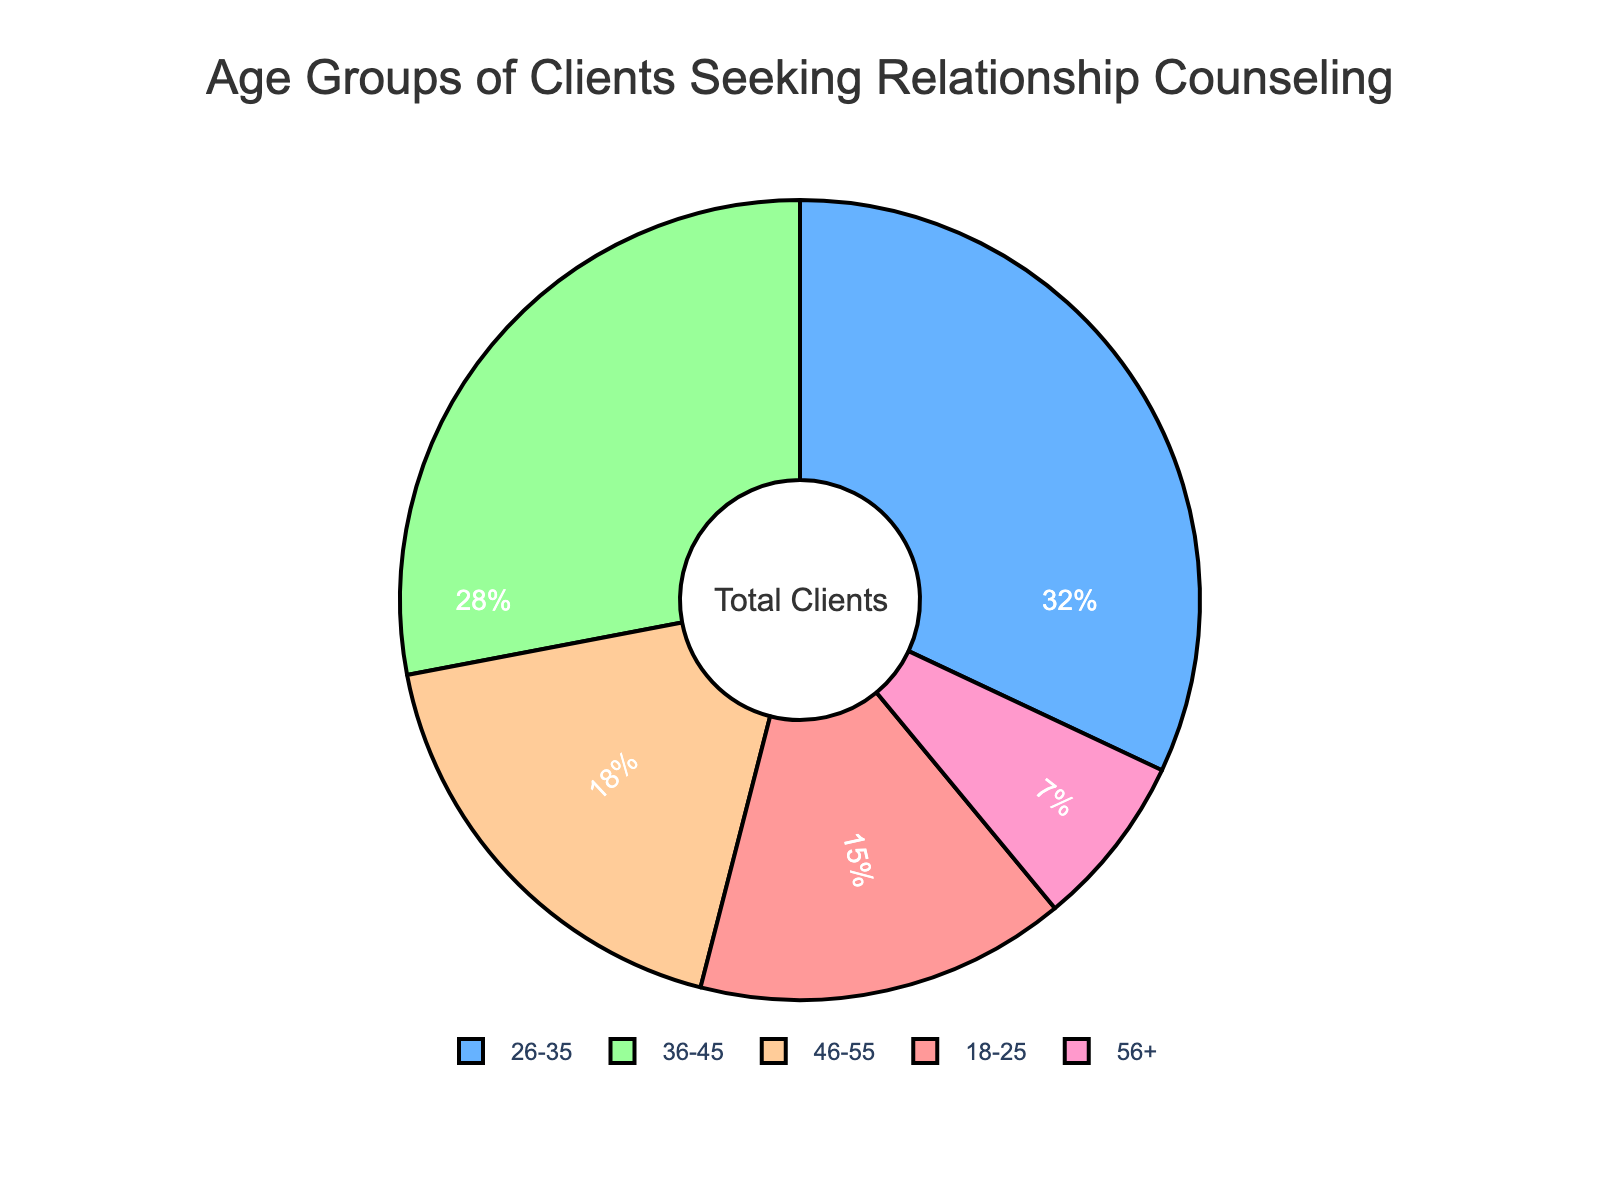What percentage of the clients are aged 26-35? By observing the pie chart, locate the section labeled '26-35' and check the associated percentage value.
Answer: 32% Which age group has the smallest percentage of clients? Identify the sections in the pie chart and compare their sizes. The smallest section corresponds to the age group with the smallest percentage.
Answer: 56+ How much more percentage do clients aged 26-35 have compared to those aged 56+? Find the percentages of clients for the age groups 26-35 and 56+ in the pie chart. Calculate the difference: 32% - 7% = 25%.
Answer: 25% What is the combined percentage of clients aged 36-45 and 46-55? Locate the percentages for age groups 36-45 and 46-55 in the pie chart. Sum the values: 28% + 18% = 46%.
Answer: 46% Which age group has a larger percentage of clients: 18-25 or 46-55? Compare the percentages of the 18-25 and 46-55 age groups. Find the larger one.
Answer: 46-55 What are the colors representing the age groups 26-35 and 56+? Observe the colors of the sections labeled '26-35' and '56+' in the pie chart.
Answer: Light blue (26-35), pink (56+) How many age groups have a percentage higher than 20%? Analyze the pie chart and count the number of sections with percentages greater than 20%.
Answer: 2 (26-35 and 36-45) What is the difference in percentage between the age groups 18-25 and 36-45? Find the percentages of clients for age groups 18-25 and 36-45. Calculate the difference: 28% - 15% = 13%.
Answer: 13% Which age group occupies approximately one-third of the pie chart? Identify the section in the pie chart that visually appears to cover around one-third. Verify by checking the percentage value.
Answer: 26-35 